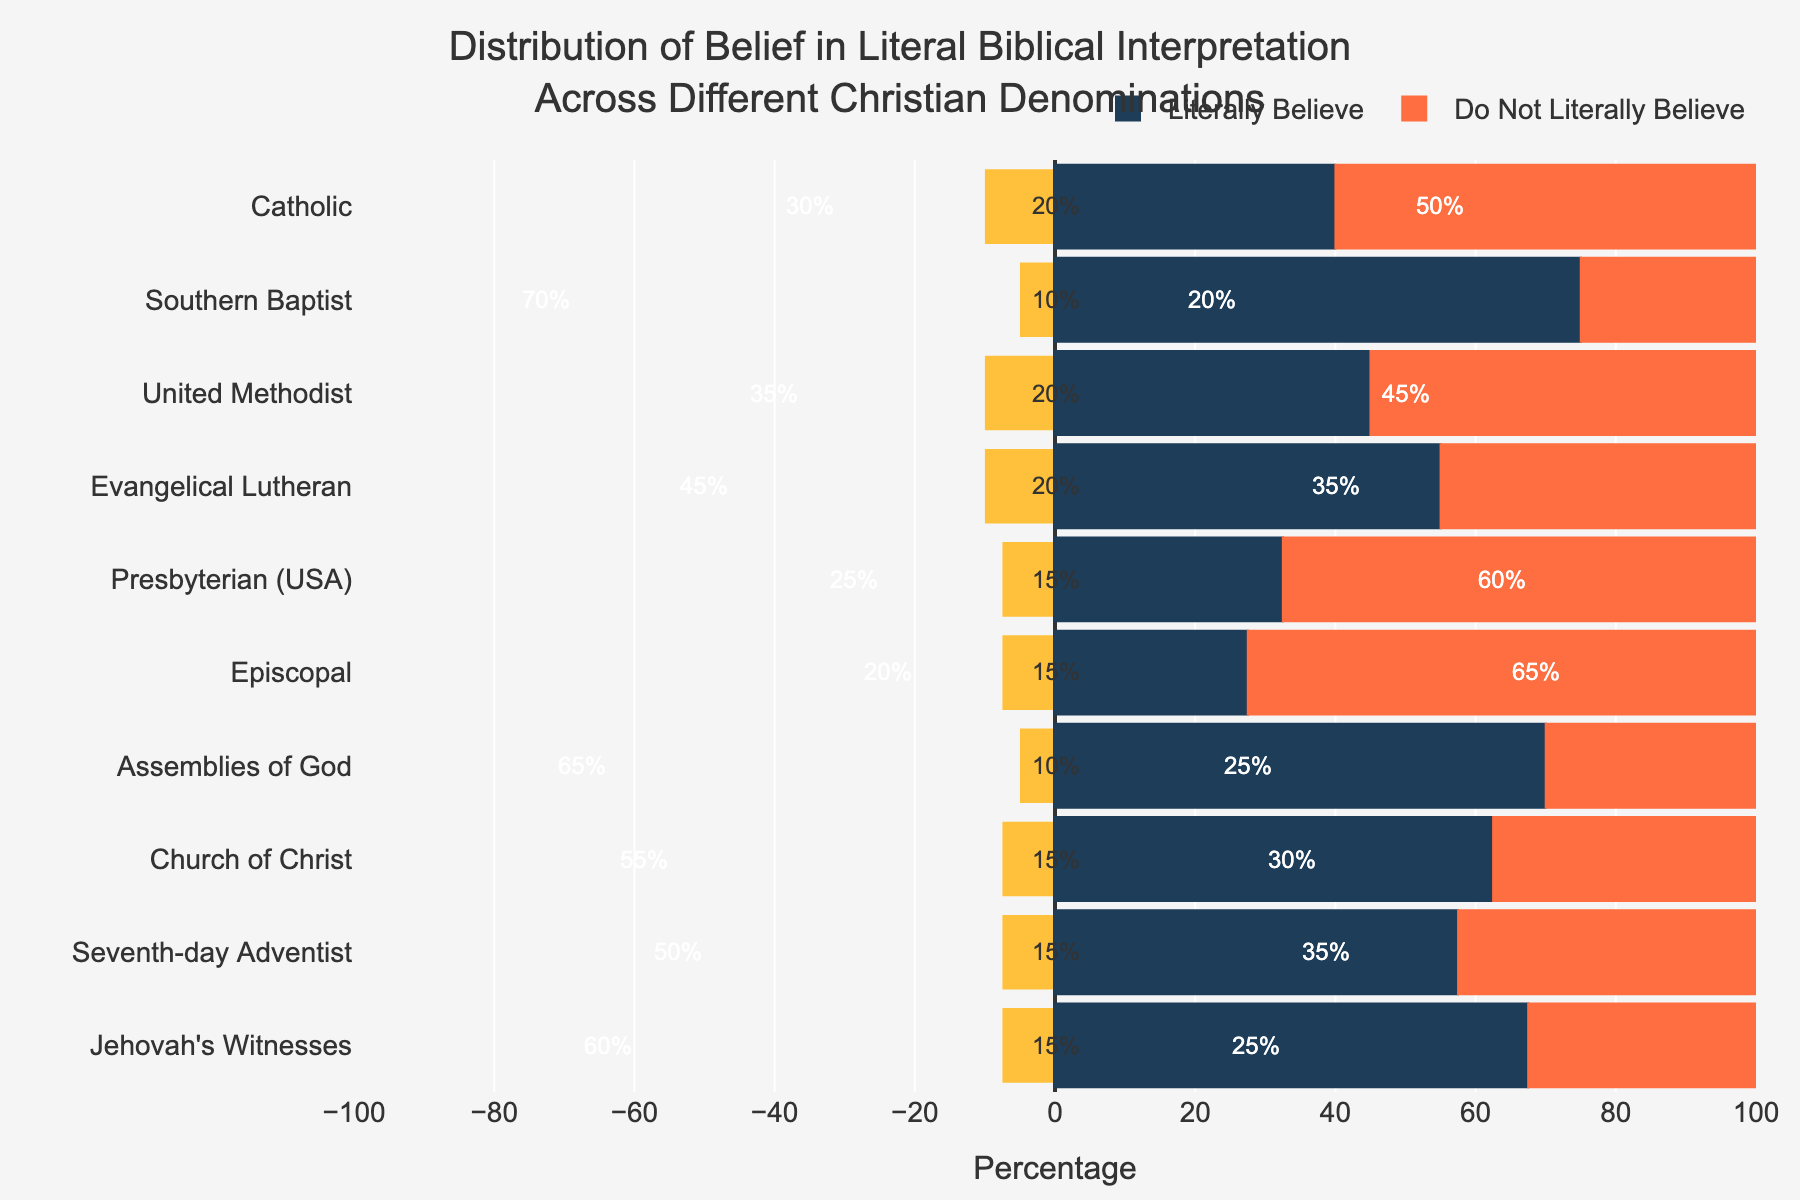What percentage of Southern Baptists believe in a literal interpretation of the Bible? Look at the "Literally Believe" bar for Southern Baptists. The percentage is annotated directly on the bar.
Answer: 70% Which denomination has the highest percentage of members who do not believe in a literal interpretation of the Bible? Compare the "Do Not Literally Believe" bars for all denominations. The denomination with the highest bar length and value is Episcopal.
Answer: Episcopal Which two denominations have the same percentage of neutral beliefs regarding biblical interpretation? Identify the denominations with the same value in the "Neutral" annotation. Both United Methodist and Evangelical Lutheran have 20%.
Answer: United Methodist and Evangelical Lutheran What is the difference in the percentage of literal belief between Catholics and the Assemblies of God? Subtract the percentage of Catholics who believe literally (30%) from the percentage for Assemblies of God (65%). 65% - 30% = 35%.
Answer: 35% Among Jehovah's Witnesses, what percentage of members do not literally believe in the Bible compared to the neutral ones? Look at the "Do Not Literally Believe" and "Neutral" bars for Jehovah's Witnesses. The values are annotated directly: 25% do not believe literally, and 15% are neutral.
Answer: 25% and 15% Which denomination has the highest spread between literal and non-literal believers? Calculate the spread for each denomination by finding the absolute difference between "Literally Believe" and "Do Not Literally Believe". The Southern Baptist has the highest spread: 70% - 20% = 50%.
Answer: Southern Baptist How does the percentage of literal belief in Evangelical Lutherans compare to that in Presbyterians (USA)? Compare the "Literally Believe" bar lengths. Evangelical Lutherans have 45%, while Presbyterians (USA) have 25%.
Answer: Evangelical Lutherans have a higher percentage What is the total percentage of non-literal believers in Catholic, Southern Baptist, and Jehovah's Witnesses combined? Add the values for "Do Not Literally Believe" in the given denominations: 50% (Catholic) + 20% (Southern Baptist) + 25% (Jehovah's Witnesses). 50 + 20 + 25 = 95%.
Answer: 95% Which group has more literal believers: Seventh-day Adventists or Church of Christ? Compare the "Literally Believe" bars. Seventh-day Adventists have 50%, while Church of Christ has 55%.
Answer: Church of Christ What is the average percentage of literal belief among all denominations? Sum the "Literally Believe" values for all denominations and divide by the number of denominations: (30 + 70 + 35 + 45 + 25 + 20 + 65 + 55 + 50 + 60) / 10 = 45%.
Answer: 45% 